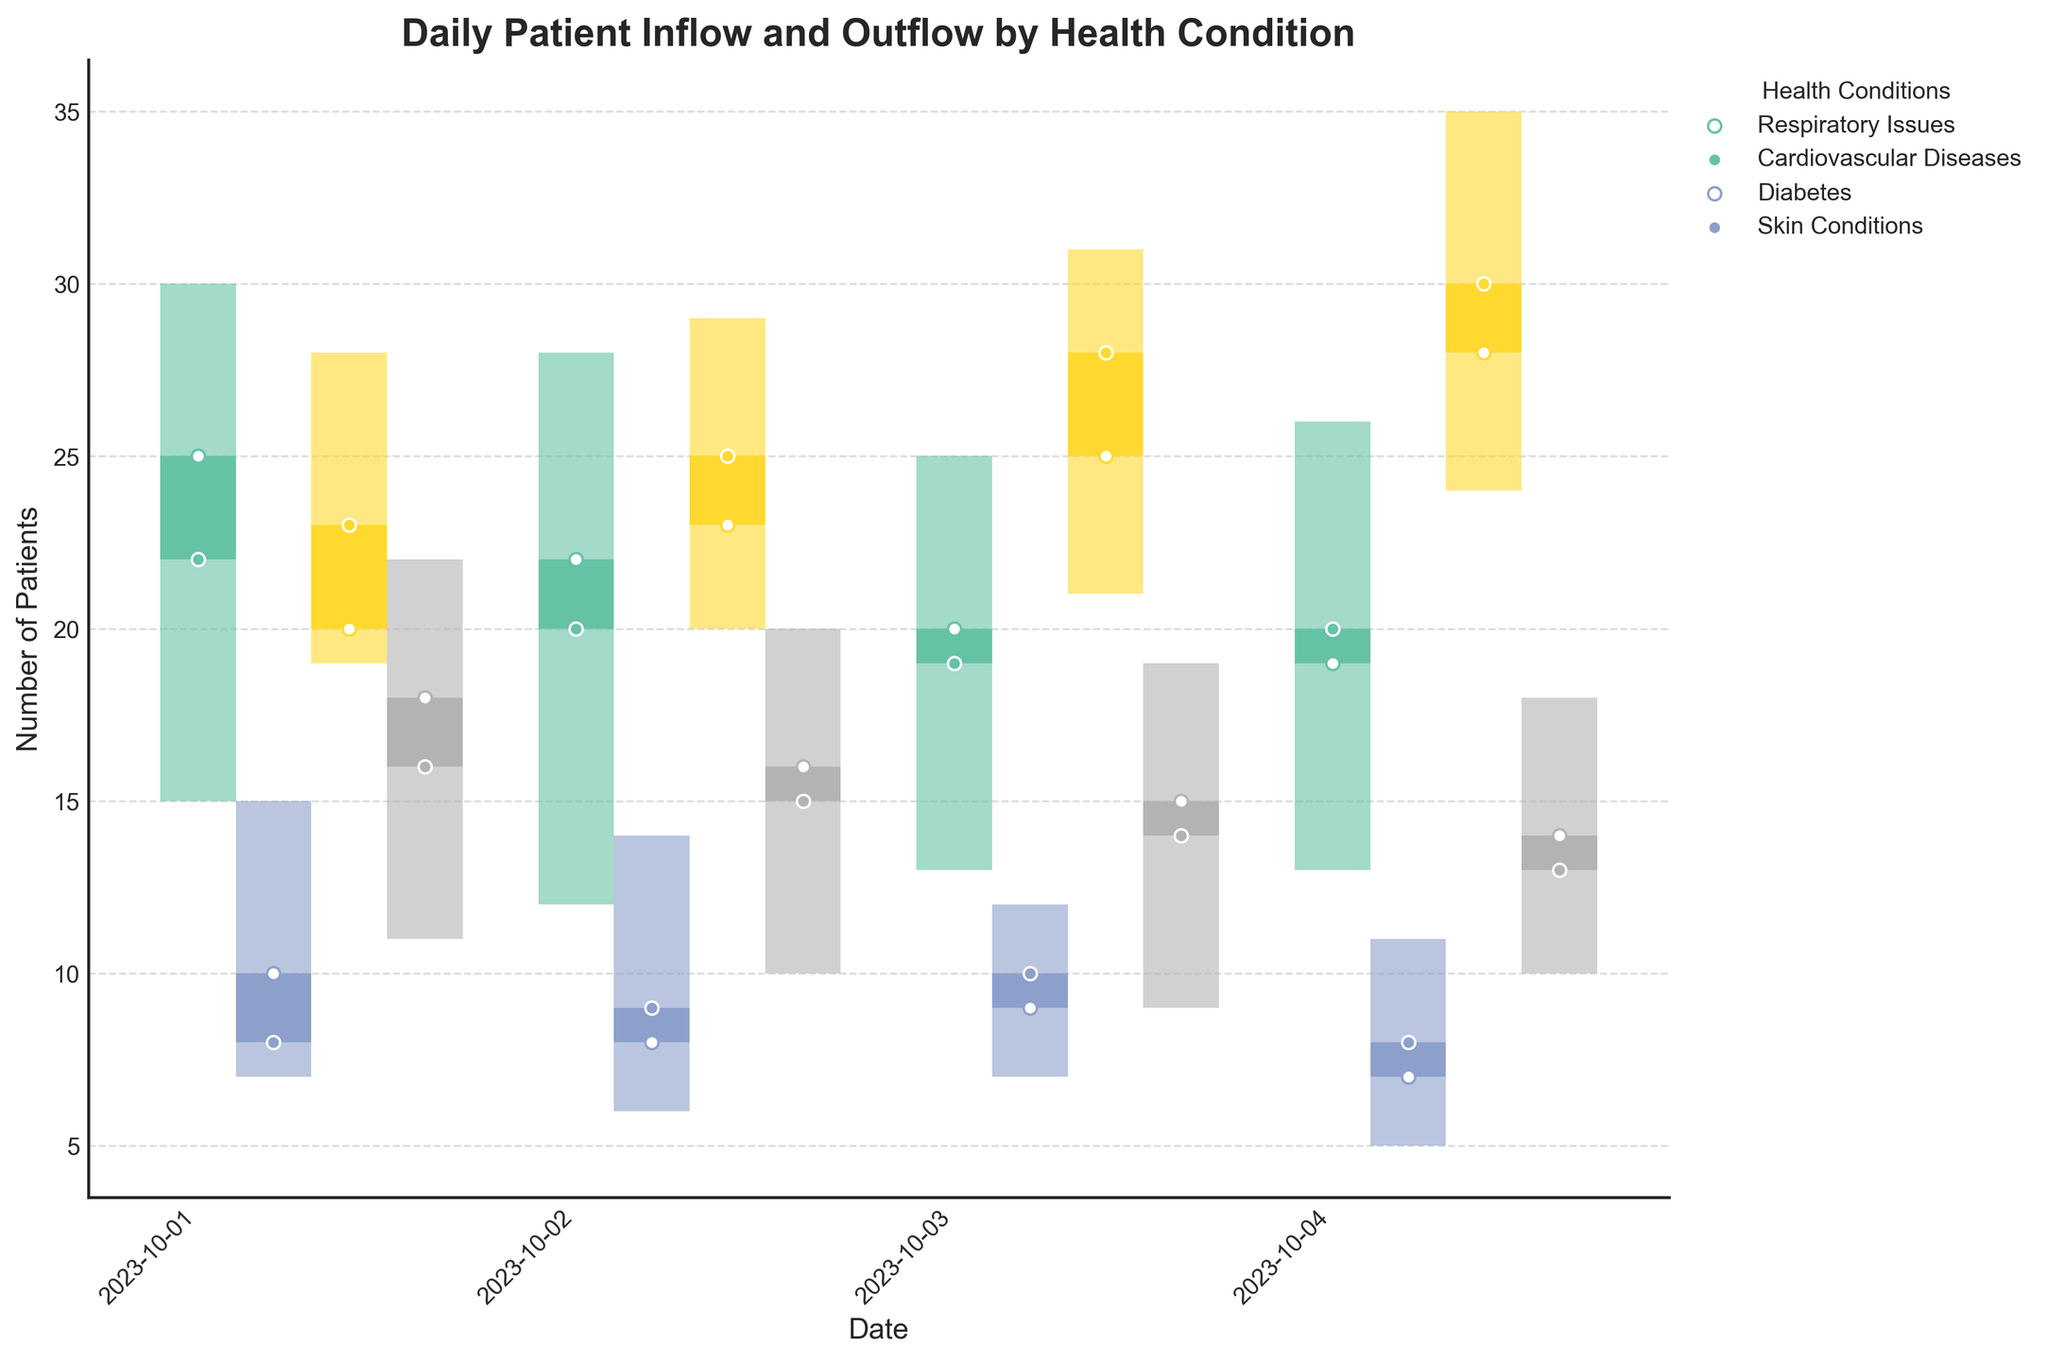what is the title of the plot? Look at the top center of the figure where the title is located.
Answer: Daily Patient Inflow and Outflow by Health Condition Which health condition had the highest number of patients on October 3rd? Refer to the "High" value for each condition on October 3rd to find the highest number. Respiratory Issues: 25, Cardiovascular Diseases: 12, Diabetes: 31, Skin Conditions: 19.
Answer: Diabetes What is the color used to represent Cardiovascular Diseases? Check the legend at the bottom of the graph to find the color associated with Cardiovascular Diseases.
Answer: The color used for Cardiovascular Diseases as shown in the legend Which health condition showed the largest difference between the high and low values on October 4th? Subtract the "Low" value from the "High" value for each condition on October 4th. Respiratory Issues: 26-13=13, Cardiovascular Diseases: 11-5=6, Diabetes: 35-24=11, Skin Conditions: 18-10=8.
Answer: Respiratory Issues Which day had the highest total patient inflow for Diabetes? Compare the "High" values for Diabetes across all dates: October 1st: 28, October 2nd: 29, October 3rd: 31, October 4th: 35.
Answer: October 4th On October 2nd, did more Respiratory Issues patients enter or leave the field doctor’s care? Compare the "Open" and "Close" values for Respiratory Issues on October 2nd. Open: 22, Close: 20, indicating more patients entered than left.
Answer: Enter How does the closing value of Cardiovascular Diseases on October 1st compare with October 4th? Check the "Close" values for Cardiovascular Diseases on both dates: October 1st: 8, October 4th: 8. Both values are the same.
Answer: Equal For Diabetes, what was the average number of patients at the close over the four days? Add up the "Close" values for Diabetes for all dates and divide by 4. The "Close" values are 23, 25, 28, 30. So (23 + 25 + 28 + 30) / 4 = 26.5.
Answer: 26.5 What health condition had the largest increase in patient outflow from October 1st to October 2nd? Calculate the difference in "Close" values for each condition between the two days. Respiratory Issues: 20-22=-2, Cardiovascular Diseases: 9-8=1, Diabetes: 25-23=2, Skin Conditions: 15-16=-1.
Answer: Cardiovascular Diseases 